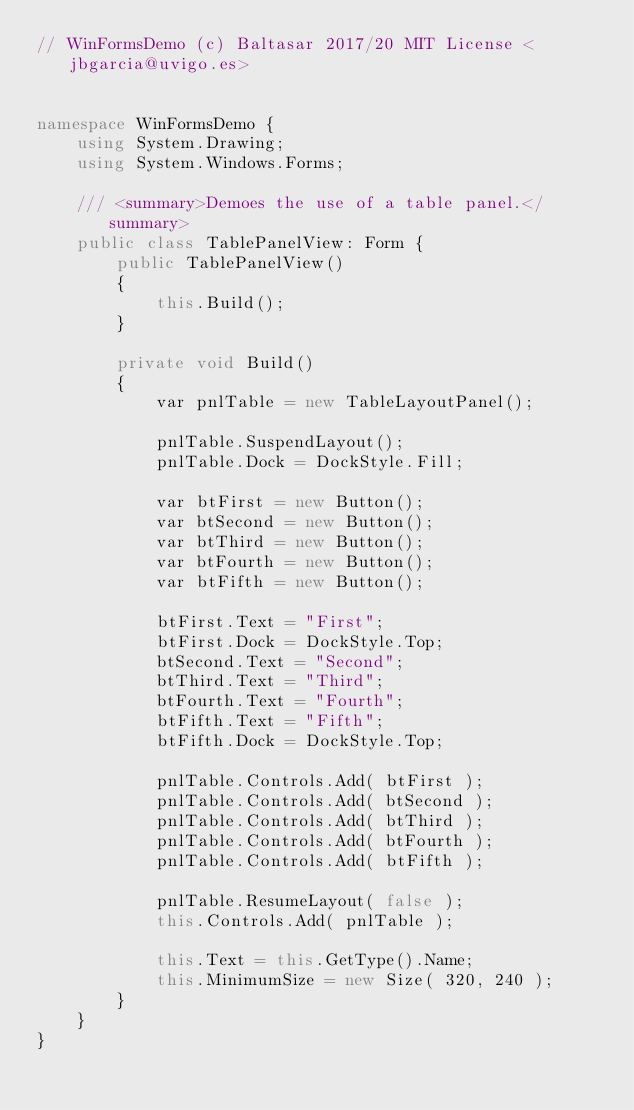Convert code to text. <code><loc_0><loc_0><loc_500><loc_500><_C#_>// WinFormsDemo (c) Baltasar 2017/20 MIT License <jbgarcia@uvigo.es>


namespace WinFormsDemo {
    using System.Drawing;
    using System.Windows.Forms;

    /// <summary>Demoes the use of a table panel.</summary>
	public class TablePanelView: Form {
		public TablePanelView()
		{
			this.Build();
		}

		private void Build()
		{
			var pnlTable = new TableLayoutPanel();

			pnlTable.SuspendLayout();
			pnlTable.Dock = DockStyle.Fill;

			var btFirst = new Button();
			var btSecond = new Button();
			var btThird = new Button();
			var btFourth = new Button();
			var btFifth = new Button();

			btFirst.Text = "First";
			btFirst.Dock = DockStyle.Top;
			btSecond.Text = "Second";
			btThird.Text = "Third";
			btFourth.Text = "Fourth";
			btFifth.Text = "Fifth";
			btFifth.Dock = DockStyle.Top;

			pnlTable.Controls.Add( btFirst );
			pnlTable.Controls.Add( btSecond );
			pnlTable.Controls.Add( btThird );
			pnlTable.Controls.Add( btFourth );
			pnlTable.Controls.Add( btFifth );

			pnlTable.ResumeLayout( false );
			this.Controls.Add( pnlTable );

            this.Text = this.GetType().Name;
			this.MinimumSize = new Size( 320, 240 );
		}
	}
}

</code> 